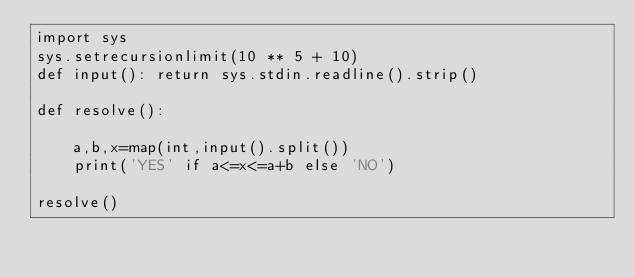<code> <loc_0><loc_0><loc_500><loc_500><_Python_>import sys
sys.setrecursionlimit(10 ** 5 + 10)
def input(): return sys.stdin.readline().strip()

def resolve():
    
    a,b,x=map(int,input().split())
    print('YES' if a<=x<=a+b else 'NO')
    
resolve()</code> 